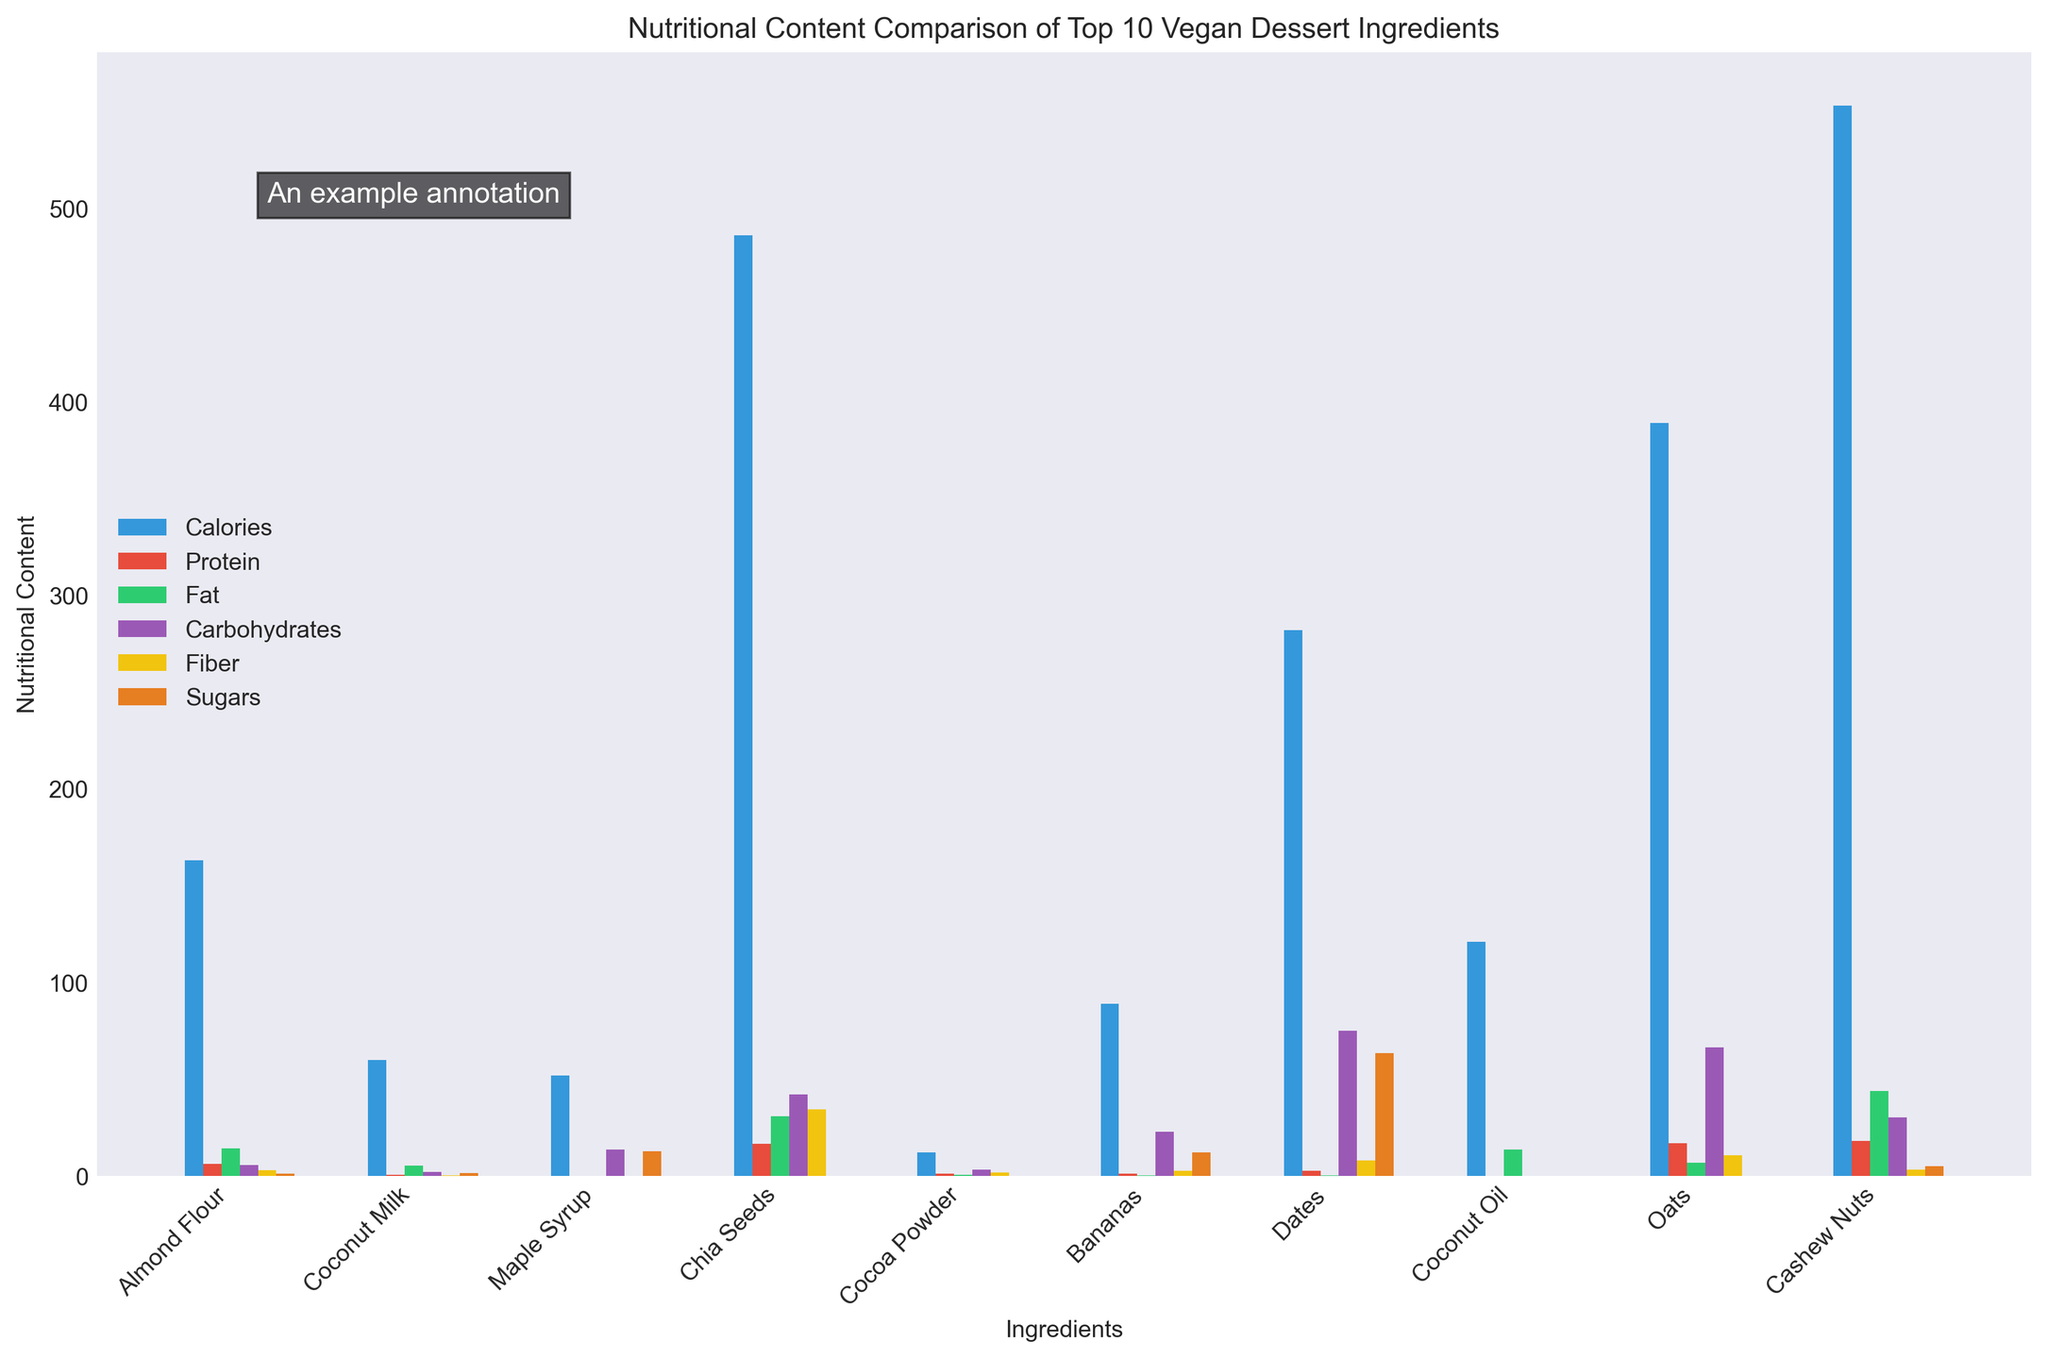How many ingredients have more than 10 grams of protein? To find the answer, look at the "Protein" bars for each ingredient and count the number of bars that extend above the 10-gram mark.
Answer: 3 Which ingredient has the highest amount of fiber? To find the highest amount of fiber, identify the tallest "Fiber" bar (colored yellow) among all the ingredients.
Answer: Chia Seeds Which ingredient has the darkest red bar visible, representing the highest sugars content? The darkest red bar, representing sugars, corresponds to the ingredient with the tallest such bar.
Answer: Dates What is the average amount of carbohydrates in Oats and Bananas together? The amount of carbohydrates in Oats is 66.3 grams, and in Bananas is 22.8 grams. Sum these values and divide by 2 to find the average: (66.3 + 22.8)/2 = 44.55
Answer: 44.55 Does Almond Flour have more fat or protein? Compare the lengths of the blue bar (protein) and green bar (fat) for Almond Flour. The taller bar indicates the higher content.
Answer: Fat What color represents calories in the bar chart? Identify the bar color associated with the "Calories" label in the legend.
Answer: Blue Which ingredient has the lowest calorie content? Find the shortest "Calories" bar (colored blue) among all ingredients.
Answer: Cocoa Powder What is the total amount of sugars in Bananas and Maple Syrup? Add the amount of sugars in Bananas (12.2 grams) and Maple Syrup (12.7 grams): 12.2 + 12.7 = 24.9
Answer: 24.9 Which ingredient has more fiber, Cashew Nuts or Dates? Compare the yellow bars representing fiber for Cashew Nuts and Dates. The taller bar indicates higher fiber content.
Answer: Dates 